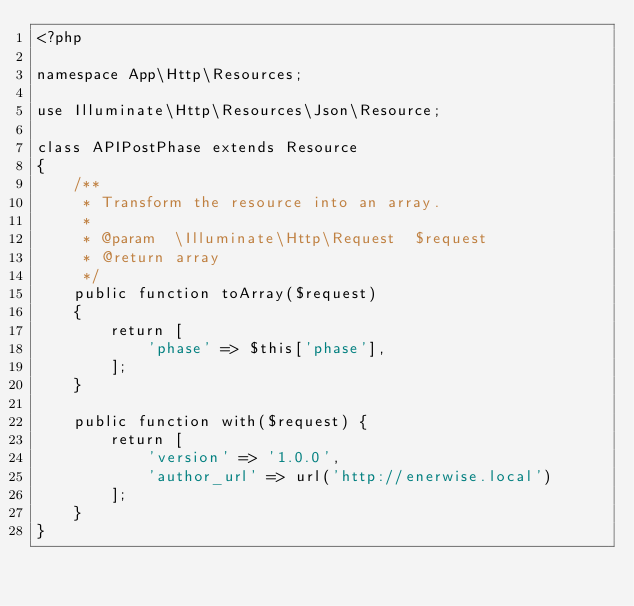Convert code to text. <code><loc_0><loc_0><loc_500><loc_500><_PHP_><?php

namespace App\Http\Resources;

use Illuminate\Http\Resources\Json\Resource;

class APIPostPhase extends Resource
{
    /**
     * Transform the resource into an array.
     *
     * @param  \Illuminate\Http\Request  $request
     * @return array
     */
    public function toArray($request)
    {
        return [
            'phase' => $this['phase'],
        ];
    }

    public function with($request) {
        return [
            'version' => '1.0.0',
            'author_url' => url('http://enerwise.local')
        ];
    }
}
</code> 